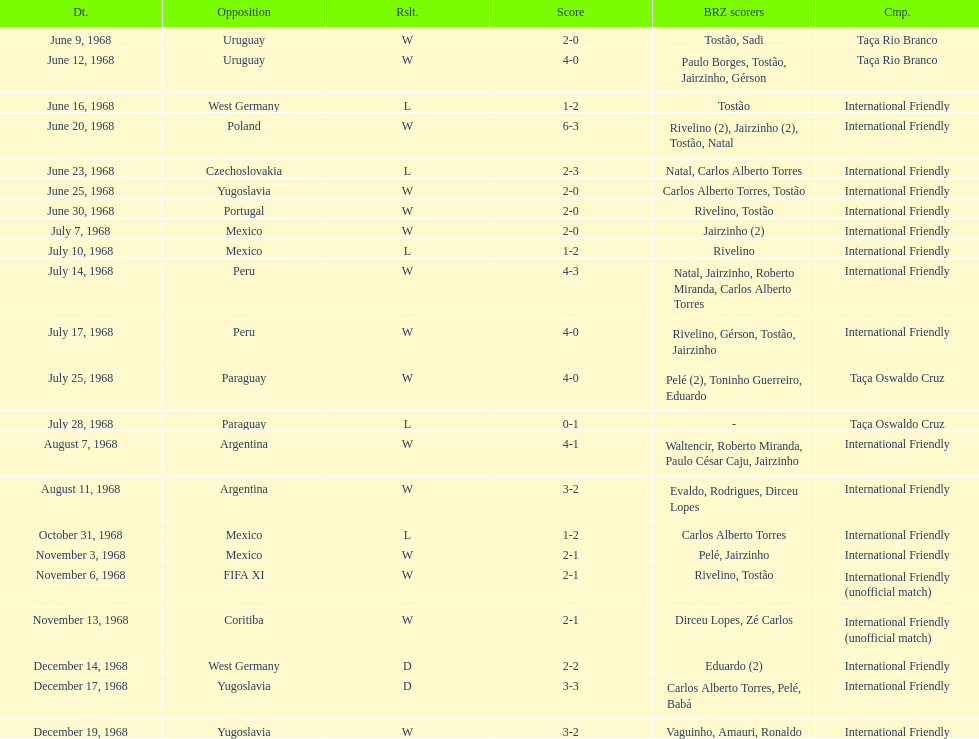How many times did brazil score during the game on november 6th? 2. 